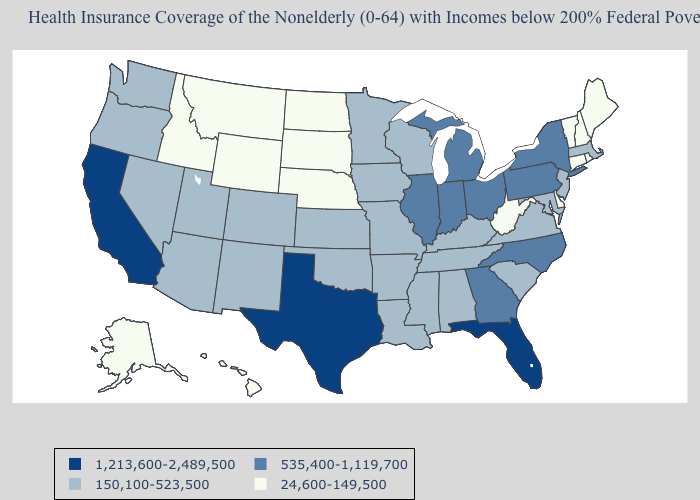What is the lowest value in the USA?
Write a very short answer. 24,600-149,500. What is the highest value in the West ?
Be succinct. 1,213,600-2,489,500. What is the value of Virginia?
Concise answer only. 150,100-523,500. Name the states that have a value in the range 535,400-1,119,700?
Keep it brief. Georgia, Illinois, Indiana, Michigan, New York, North Carolina, Ohio, Pennsylvania. Name the states that have a value in the range 24,600-149,500?
Short answer required. Alaska, Connecticut, Delaware, Hawaii, Idaho, Maine, Montana, Nebraska, New Hampshire, North Dakota, Rhode Island, South Dakota, Vermont, West Virginia, Wyoming. What is the lowest value in the USA?
Answer briefly. 24,600-149,500. Does Ohio have a higher value than Texas?
Answer briefly. No. How many symbols are there in the legend?
Answer briefly. 4. Which states have the highest value in the USA?
Short answer required. California, Florida, Texas. Is the legend a continuous bar?
Answer briefly. No. What is the lowest value in the USA?
Write a very short answer. 24,600-149,500. Does Vermont have the highest value in the Northeast?
Concise answer only. No. Which states have the highest value in the USA?
Short answer required. California, Florida, Texas. Which states have the lowest value in the MidWest?
Write a very short answer. Nebraska, North Dakota, South Dakota. Among the states that border Maryland , does Delaware have the highest value?
Concise answer only. No. 